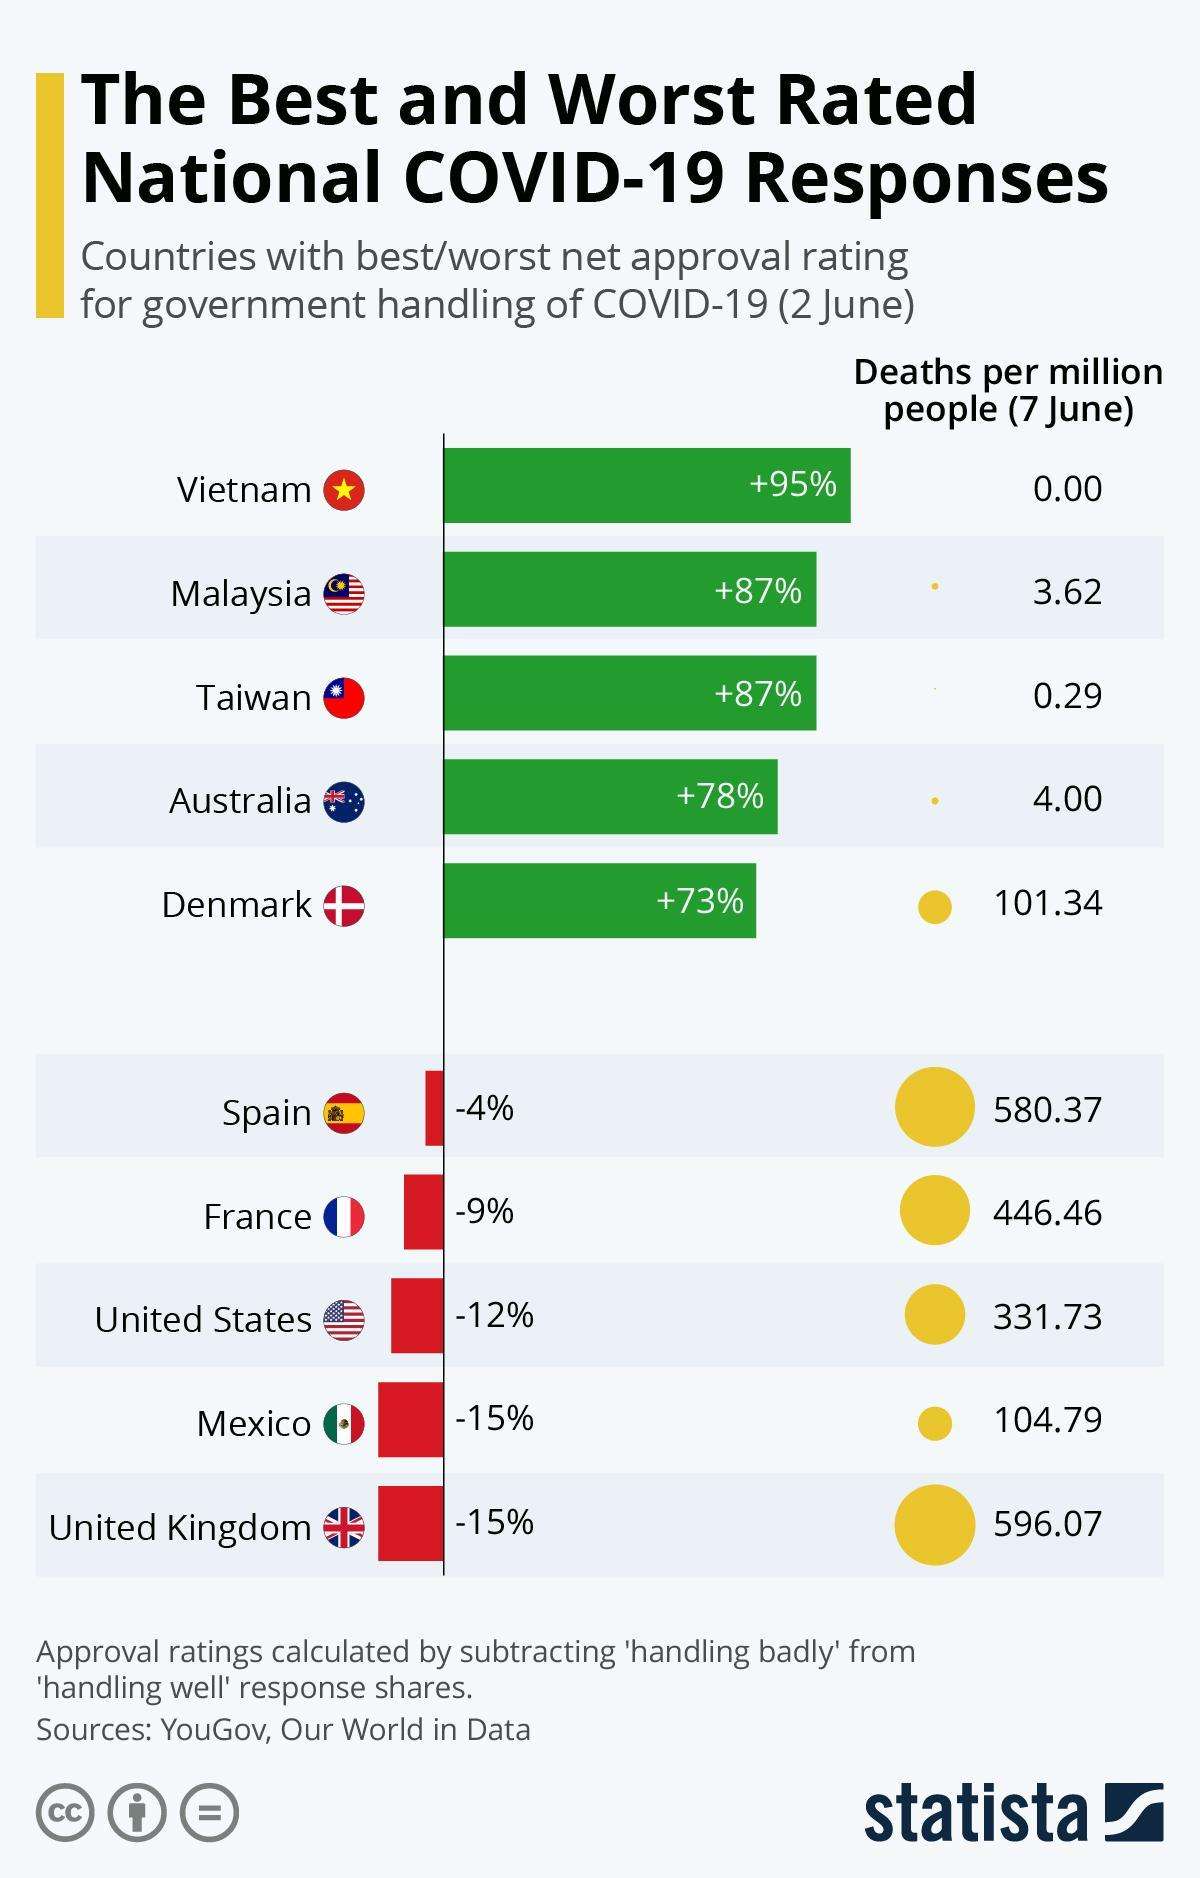What is the number of deaths per million people as of 7 June in Denmark?
Answer the question with a short phrase. 101.34 Which country has the least number of deaths per million people as of 7 June? Vietnam What is the net approval rating for government handling of COVID-19 in Australia as of 2 June? +78% Which country has the highest number of deaths per million people as of 7 June? United Kingdom What is the number of deaths per million people as of 7 June in Taiwan? 0.29 Which country has the best net approval rating for government handling of COVID-19 as of 2 June? Vietnam What is the net approval rating for government handling of COVID-19 in Spain as of 2 June? -4% 